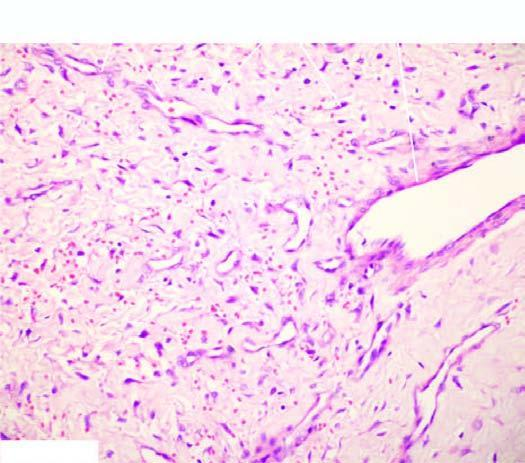re b, the opened up chambers of the heart variable-sized?
Answer the question using a single word or phrase. No 